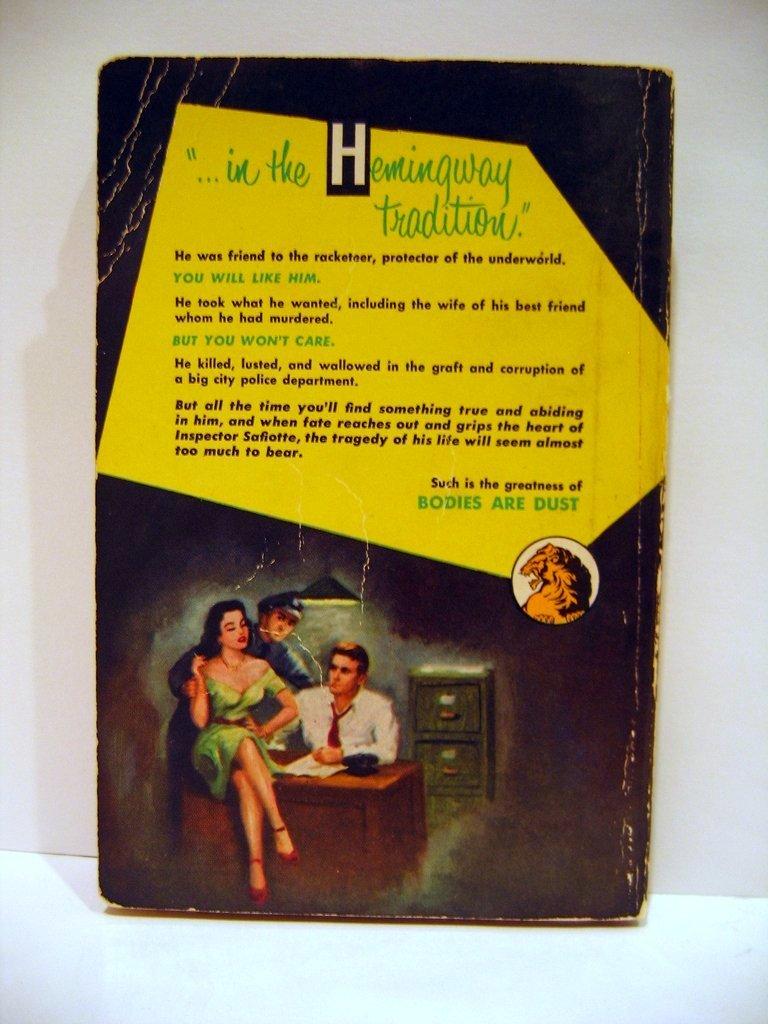Which famous author is being discussed?
Offer a very short reply. Hemingway. 